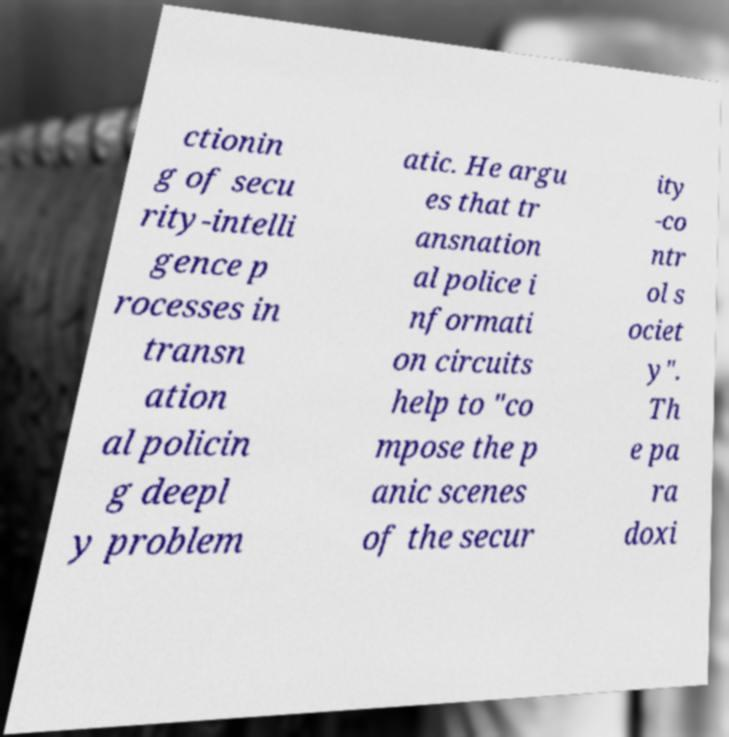Could you assist in decoding the text presented in this image and type it out clearly? ctionin g of secu rity-intelli gence p rocesses in transn ation al policin g deepl y problem atic. He argu es that tr ansnation al police i nformati on circuits help to "co mpose the p anic scenes of the secur ity -co ntr ol s ociet y". Th e pa ra doxi 